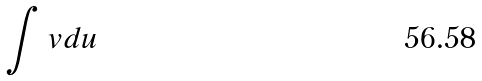<formula> <loc_0><loc_0><loc_500><loc_500>\int v d u</formula> 